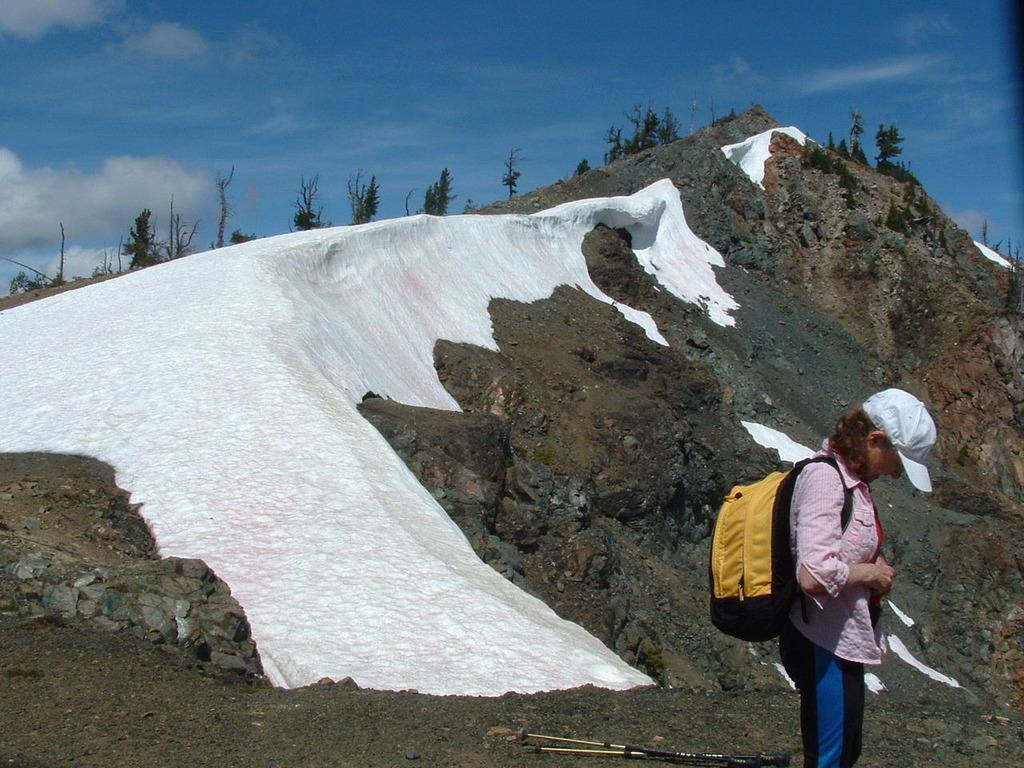What can be seen in the image? There is a person standing in the image. Can you describe the person's attire? The person is wearing a white cap. What is the person carrying in the image? The person is carrying a black and yellow bag. What can be seen in the background of the image? There are mountains, snow, and trees visible in the background of the image. What card game is the person playing in the image? There is no card game visible in the image; the person is simply standing and carrying a bag. 